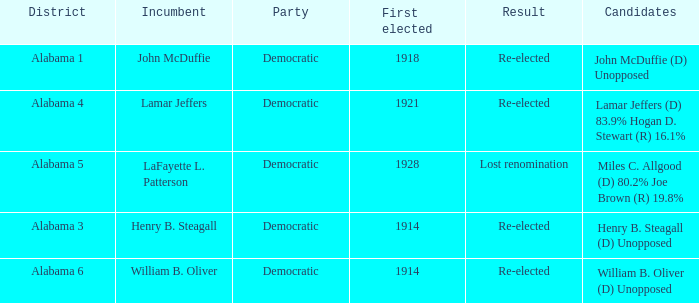How many in total were elected first in lost renomination? 1.0. 